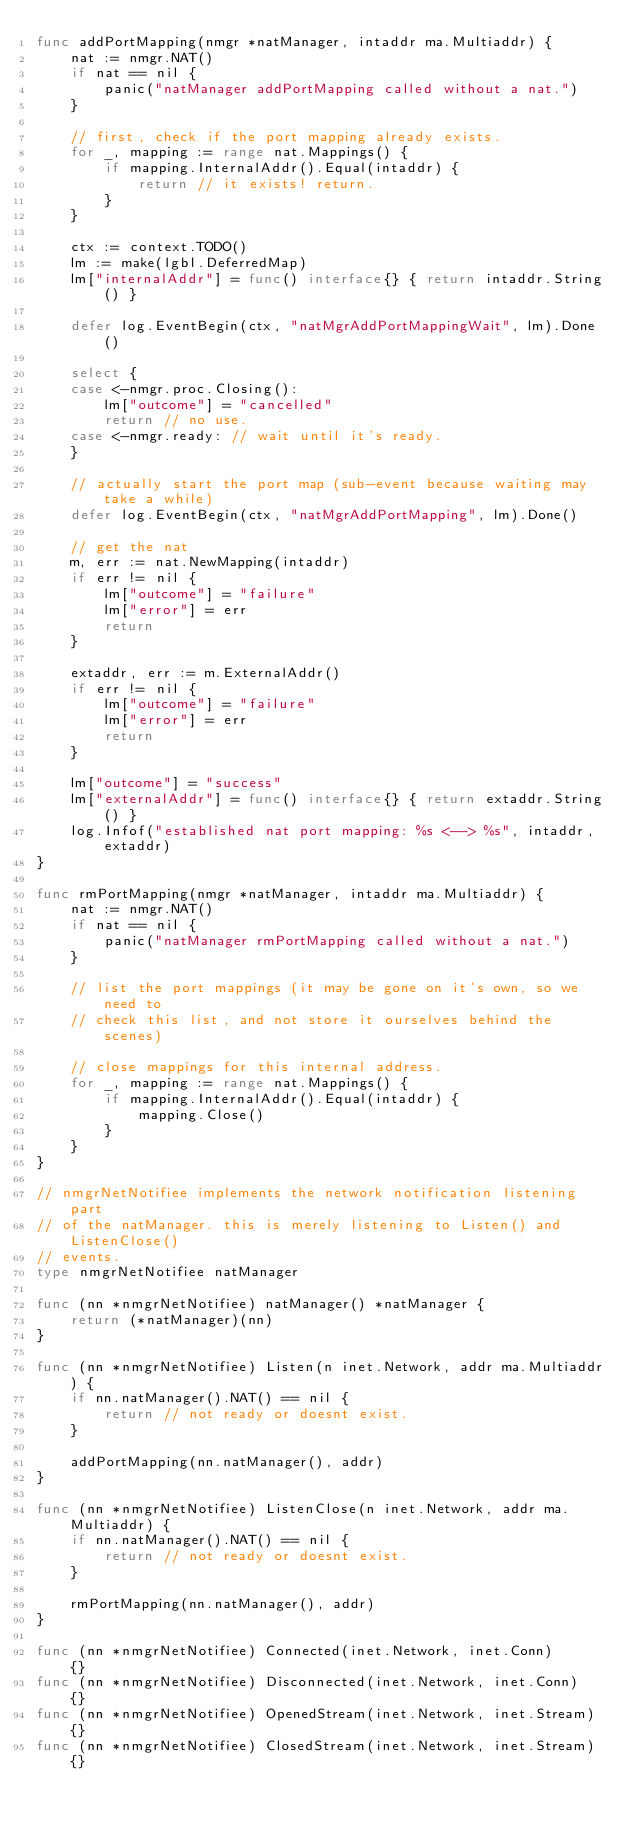Convert code to text. <code><loc_0><loc_0><loc_500><loc_500><_Go_>func addPortMapping(nmgr *natManager, intaddr ma.Multiaddr) {
	nat := nmgr.NAT()
	if nat == nil {
		panic("natManager addPortMapping called without a nat.")
	}

	// first, check if the port mapping already exists.
	for _, mapping := range nat.Mappings() {
		if mapping.InternalAddr().Equal(intaddr) {
			return // it exists! return.
		}
	}

	ctx := context.TODO()
	lm := make(lgbl.DeferredMap)
	lm["internalAddr"] = func() interface{} { return intaddr.String() }

	defer log.EventBegin(ctx, "natMgrAddPortMappingWait", lm).Done()

	select {
	case <-nmgr.proc.Closing():
		lm["outcome"] = "cancelled"
		return // no use.
	case <-nmgr.ready: // wait until it's ready.
	}

	// actually start the port map (sub-event because waiting may take a while)
	defer log.EventBegin(ctx, "natMgrAddPortMapping", lm).Done()

	// get the nat
	m, err := nat.NewMapping(intaddr)
	if err != nil {
		lm["outcome"] = "failure"
		lm["error"] = err
		return
	}

	extaddr, err := m.ExternalAddr()
	if err != nil {
		lm["outcome"] = "failure"
		lm["error"] = err
		return
	}

	lm["outcome"] = "success"
	lm["externalAddr"] = func() interface{} { return extaddr.String() }
	log.Infof("established nat port mapping: %s <--> %s", intaddr, extaddr)
}

func rmPortMapping(nmgr *natManager, intaddr ma.Multiaddr) {
	nat := nmgr.NAT()
	if nat == nil {
		panic("natManager rmPortMapping called without a nat.")
	}

	// list the port mappings (it may be gone on it's own, so we need to
	// check this list, and not store it ourselves behind the scenes)

	// close mappings for this internal address.
	for _, mapping := range nat.Mappings() {
		if mapping.InternalAddr().Equal(intaddr) {
			mapping.Close()
		}
	}
}

// nmgrNetNotifiee implements the network notification listening part
// of the natManager. this is merely listening to Listen() and ListenClose()
// events.
type nmgrNetNotifiee natManager

func (nn *nmgrNetNotifiee) natManager() *natManager {
	return (*natManager)(nn)
}

func (nn *nmgrNetNotifiee) Listen(n inet.Network, addr ma.Multiaddr) {
	if nn.natManager().NAT() == nil {
		return // not ready or doesnt exist.
	}

	addPortMapping(nn.natManager(), addr)
}

func (nn *nmgrNetNotifiee) ListenClose(n inet.Network, addr ma.Multiaddr) {
	if nn.natManager().NAT() == nil {
		return // not ready or doesnt exist.
	}

	rmPortMapping(nn.natManager(), addr)
}

func (nn *nmgrNetNotifiee) Connected(inet.Network, inet.Conn)      {}
func (nn *nmgrNetNotifiee) Disconnected(inet.Network, inet.Conn)   {}
func (nn *nmgrNetNotifiee) OpenedStream(inet.Network, inet.Stream) {}
func (nn *nmgrNetNotifiee) ClosedStream(inet.Network, inet.Stream) {}
</code> 